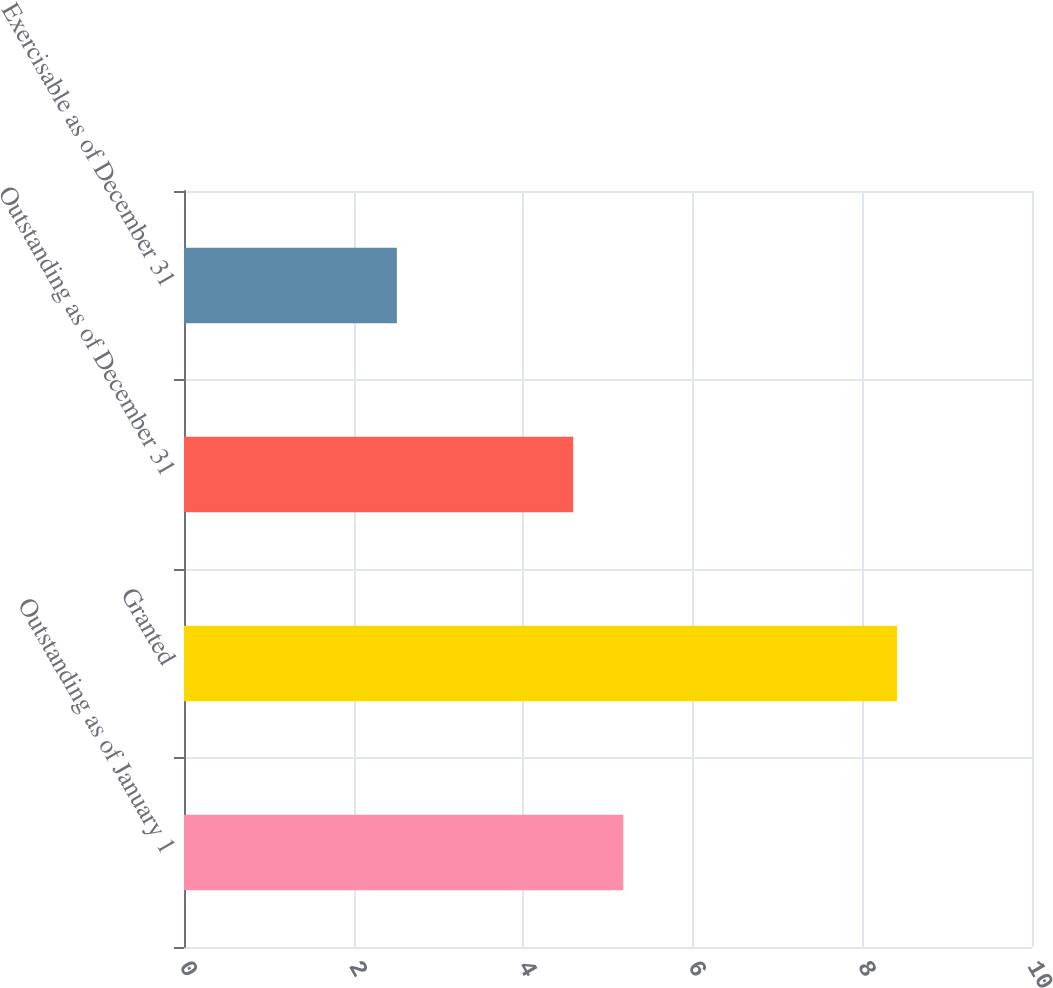Convert chart. <chart><loc_0><loc_0><loc_500><loc_500><bar_chart><fcel>Outstanding as of January 1<fcel>Granted<fcel>Outstanding as of December 31<fcel>Exercisable as of December 31<nl><fcel>5.18<fcel>8.41<fcel>4.59<fcel>2.51<nl></chart> 